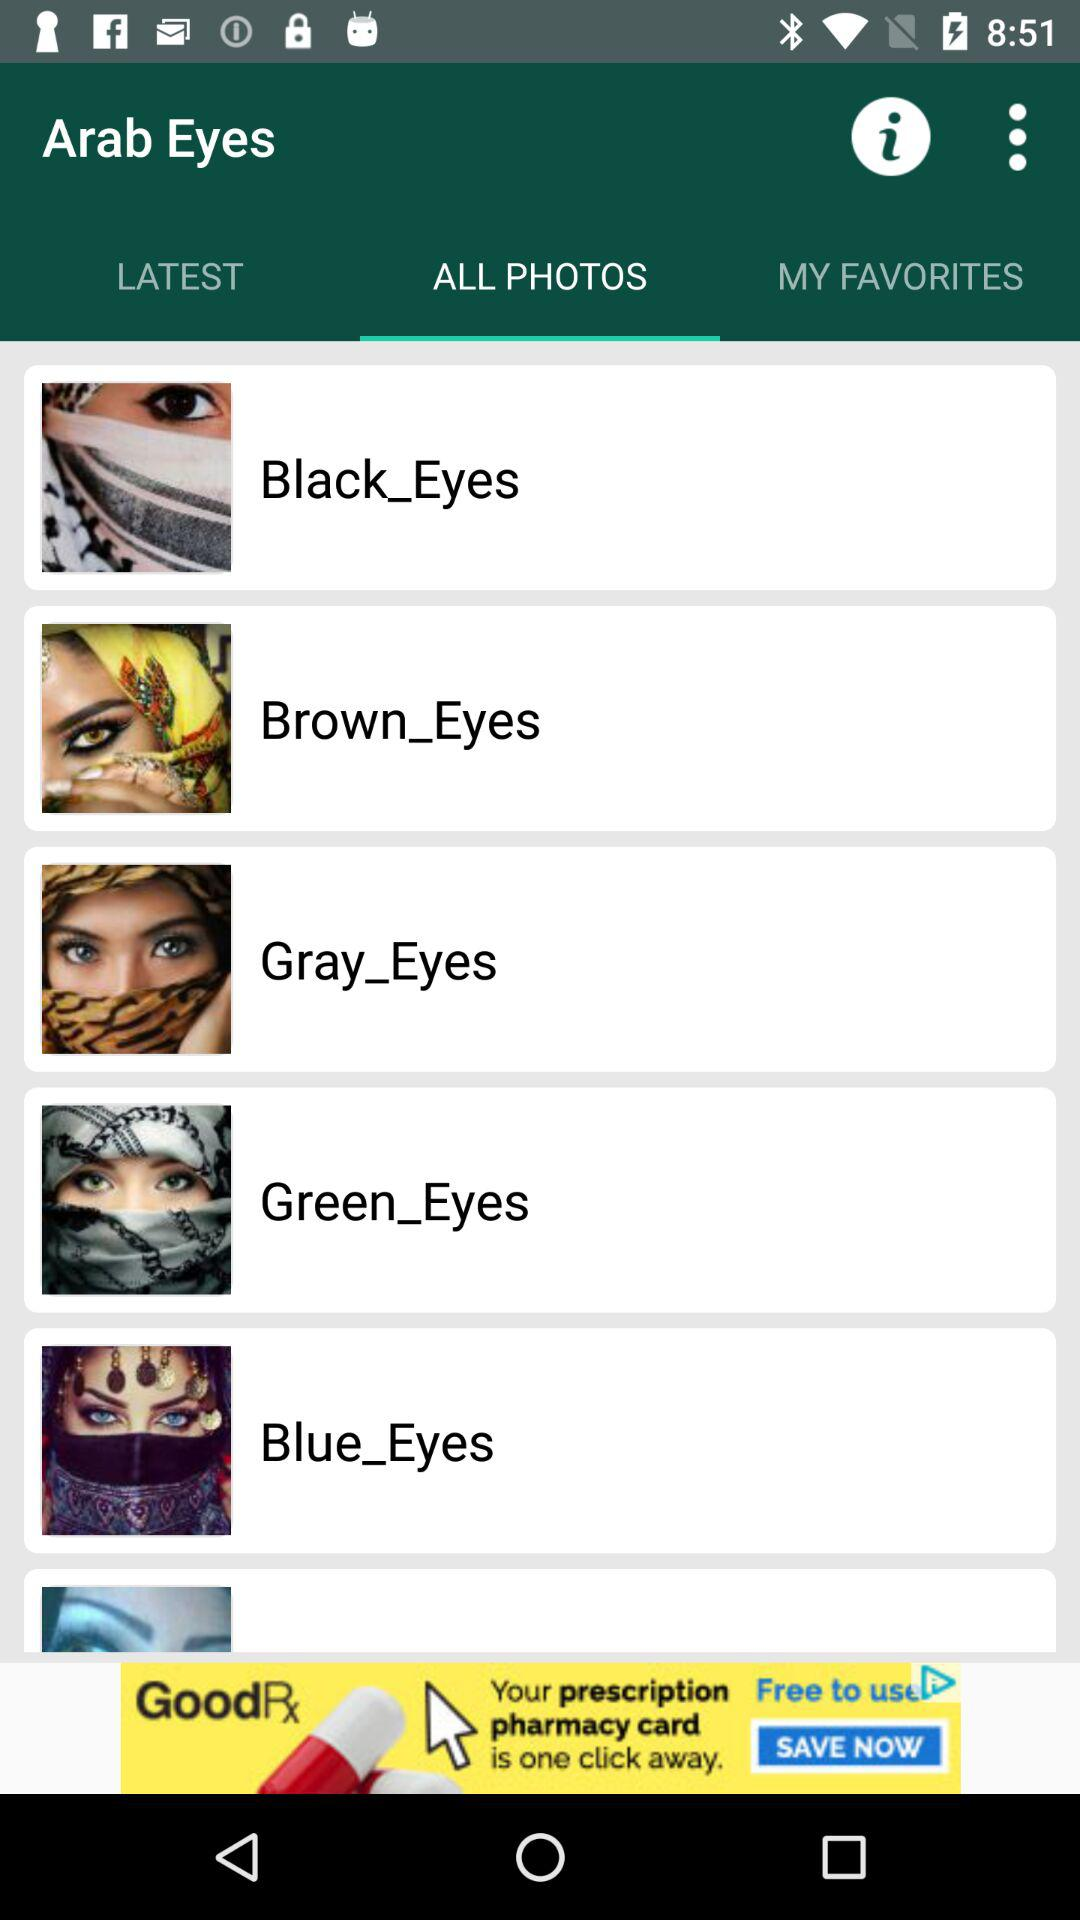What is the application name? The application name is "Arab Eyes". 